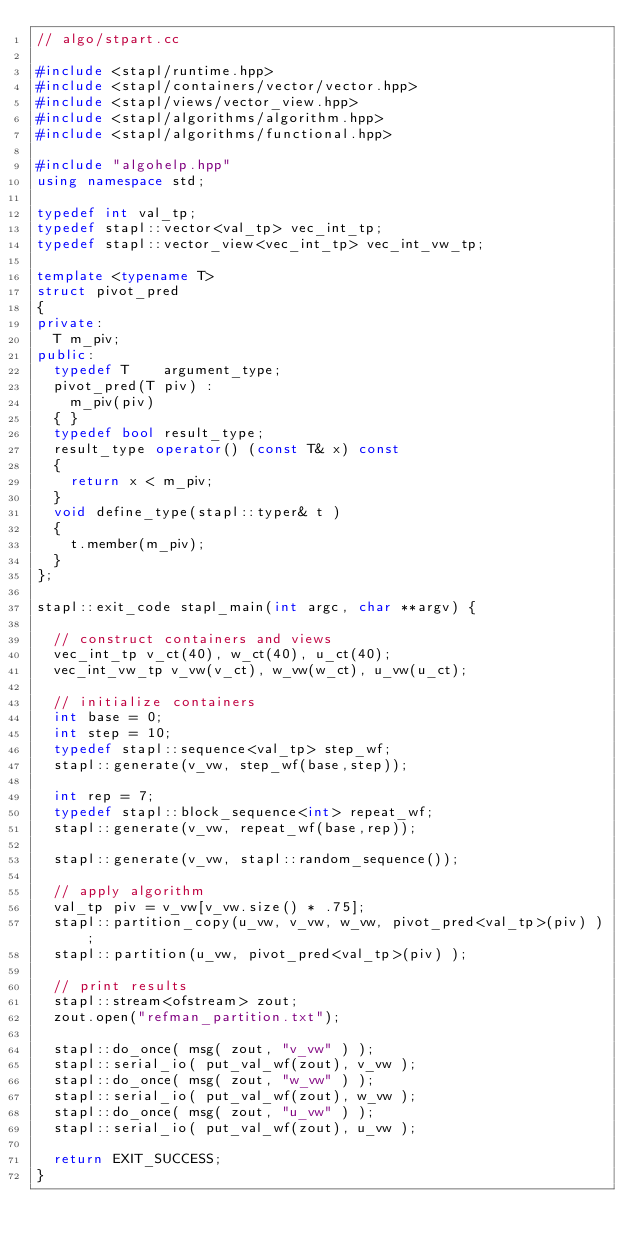<code> <loc_0><loc_0><loc_500><loc_500><_C++_>// algo/stpart.cc

#include <stapl/runtime.hpp>
#include <stapl/containers/vector/vector.hpp>
#include <stapl/views/vector_view.hpp>
#include <stapl/algorithms/algorithm.hpp>
#include <stapl/algorithms/functional.hpp>

#include "algohelp.hpp"
using namespace std;

typedef int val_tp;
typedef stapl::vector<val_tp> vec_int_tp;
typedef stapl::vector_view<vec_int_tp> vec_int_vw_tp;

template <typename T>
struct pivot_pred
{
private:
  T m_piv;
public:
  typedef T    argument_type;
  pivot_pred(T piv) :
    m_piv(piv)
  { }
  typedef bool result_type;
  result_type operator() (const T& x) const
  {
    return x < m_piv;
  }
  void define_type(stapl::typer& t )
  {
    t.member(m_piv);
  }
};

stapl::exit_code stapl_main(int argc, char **argv) {

  // construct containers and views
  vec_int_tp v_ct(40), w_ct(40), u_ct(40);
  vec_int_vw_tp v_vw(v_ct), w_vw(w_ct), u_vw(u_ct);

  // initialize containers
  int base = 0;
  int step = 10;
  typedef stapl::sequence<val_tp> step_wf;
  stapl::generate(v_vw, step_wf(base,step));

  int rep = 7;
  typedef stapl::block_sequence<int> repeat_wf;
  stapl::generate(v_vw, repeat_wf(base,rep));

  stapl::generate(v_vw, stapl::random_sequence());

  // apply algorithm
  val_tp piv = v_vw[v_vw.size() * .75];
  stapl::partition_copy(u_vw, v_vw, w_vw, pivot_pred<val_tp>(piv) );
  stapl::partition(u_vw, pivot_pred<val_tp>(piv) );

  // print results
  stapl::stream<ofstream> zout;
  zout.open("refman_partition.txt");

  stapl::do_once( msg( zout, "v_vw" ) );
  stapl::serial_io( put_val_wf(zout), v_vw );
  stapl::do_once( msg( zout, "w_vw" ) );
  stapl::serial_io( put_val_wf(zout), w_vw );
  stapl::do_once( msg( zout, "u_vw" ) );
  stapl::serial_io( put_val_wf(zout), u_vw );

  return EXIT_SUCCESS;
}
</code> 